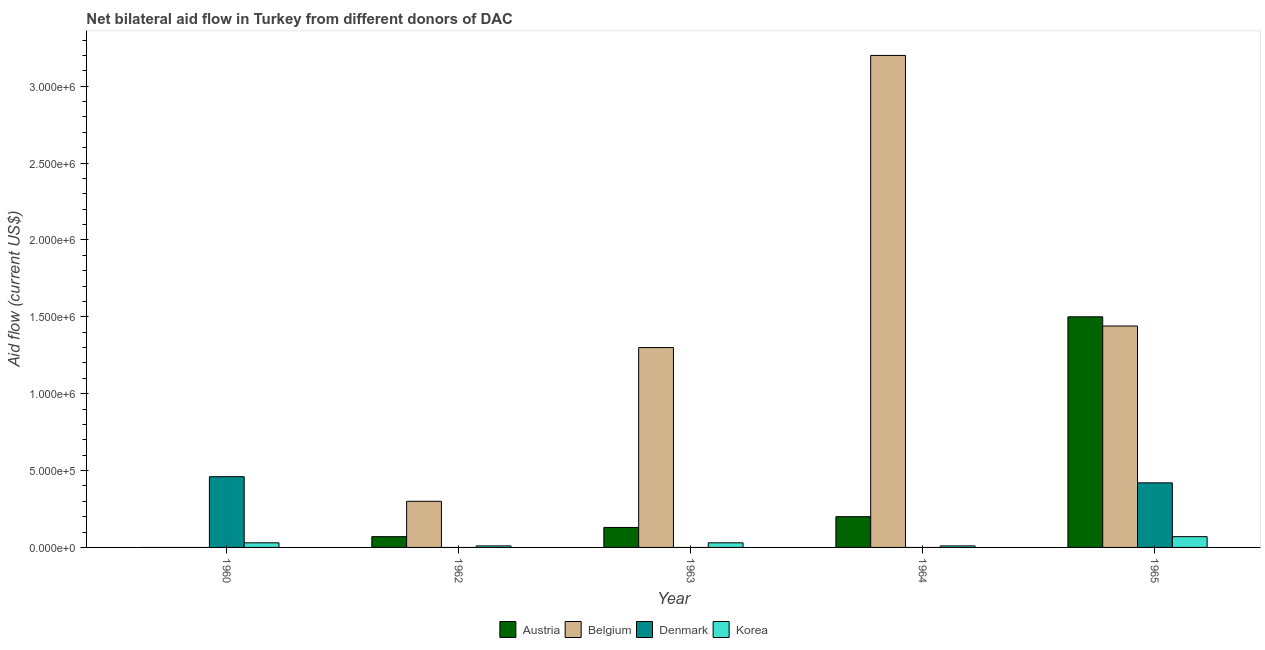How many different coloured bars are there?
Ensure brevity in your answer.  4. How many groups of bars are there?
Provide a succinct answer. 5. Are the number of bars per tick equal to the number of legend labels?
Your answer should be very brief. No. How many bars are there on the 2nd tick from the left?
Offer a terse response. 3. What is the label of the 5th group of bars from the left?
Your answer should be very brief. 1965. In how many cases, is the number of bars for a given year not equal to the number of legend labels?
Provide a short and direct response. 4. What is the amount of aid given by korea in 1963?
Make the answer very short. 3.00e+04. Across all years, what is the maximum amount of aid given by austria?
Your answer should be compact. 1.50e+06. Across all years, what is the minimum amount of aid given by denmark?
Provide a succinct answer. 0. In which year was the amount of aid given by korea maximum?
Your response must be concise. 1965. What is the total amount of aid given by austria in the graph?
Provide a short and direct response. 1.90e+06. What is the difference between the amount of aid given by belgium in 1963 and that in 1965?
Offer a terse response. -1.40e+05. What is the difference between the amount of aid given by austria in 1965 and the amount of aid given by denmark in 1962?
Offer a terse response. 1.43e+06. What is the average amount of aid given by belgium per year?
Offer a terse response. 1.25e+06. Is the amount of aid given by austria in 1962 less than that in 1964?
Your answer should be compact. Yes. Is the difference between the amount of aid given by austria in 1964 and 1965 greater than the difference between the amount of aid given by belgium in 1964 and 1965?
Provide a short and direct response. No. What is the difference between the highest and the lowest amount of aid given by austria?
Make the answer very short. 1.50e+06. Is it the case that in every year, the sum of the amount of aid given by austria and amount of aid given by korea is greater than the sum of amount of aid given by denmark and amount of aid given by belgium?
Keep it short and to the point. No. What is the difference between two consecutive major ticks on the Y-axis?
Offer a terse response. 5.00e+05. Are the values on the major ticks of Y-axis written in scientific E-notation?
Your answer should be compact. Yes. Where does the legend appear in the graph?
Make the answer very short. Bottom center. How many legend labels are there?
Give a very brief answer. 4. How are the legend labels stacked?
Provide a succinct answer. Horizontal. What is the title of the graph?
Make the answer very short. Net bilateral aid flow in Turkey from different donors of DAC. What is the Aid flow (current US$) in Denmark in 1960?
Your response must be concise. 4.60e+05. What is the Aid flow (current US$) of Denmark in 1962?
Your answer should be very brief. 0. What is the Aid flow (current US$) in Austria in 1963?
Make the answer very short. 1.30e+05. What is the Aid flow (current US$) of Belgium in 1963?
Give a very brief answer. 1.30e+06. What is the Aid flow (current US$) of Denmark in 1963?
Offer a very short reply. 0. What is the Aid flow (current US$) in Belgium in 1964?
Ensure brevity in your answer.  3.20e+06. What is the Aid flow (current US$) of Denmark in 1964?
Offer a very short reply. 0. What is the Aid flow (current US$) of Korea in 1964?
Your response must be concise. 10000. What is the Aid flow (current US$) of Austria in 1965?
Give a very brief answer. 1.50e+06. What is the Aid flow (current US$) in Belgium in 1965?
Give a very brief answer. 1.44e+06. What is the Aid flow (current US$) of Denmark in 1965?
Your response must be concise. 4.20e+05. What is the Aid flow (current US$) of Korea in 1965?
Your answer should be very brief. 7.00e+04. Across all years, what is the maximum Aid flow (current US$) in Austria?
Offer a very short reply. 1.50e+06. Across all years, what is the maximum Aid flow (current US$) of Belgium?
Your answer should be very brief. 3.20e+06. Across all years, what is the minimum Aid flow (current US$) of Austria?
Your response must be concise. 0. Across all years, what is the minimum Aid flow (current US$) of Belgium?
Your response must be concise. 0. What is the total Aid flow (current US$) of Austria in the graph?
Offer a terse response. 1.90e+06. What is the total Aid flow (current US$) of Belgium in the graph?
Ensure brevity in your answer.  6.24e+06. What is the total Aid flow (current US$) in Denmark in the graph?
Your response must be concise. 8.80e+05. What is the difference between the Aid flow (current US$) in Korea in 1960 and that in 1963?
Provide a short and direct response. 0. What is the difference between the Aid flow (current US$) in Denmark in 1960 and that in 1965?
Offer a terse response. 4.00e+04. What is the difference between the Aid flow (current US$) in Korea in 1960 and that in 1965?
Give a very brief answer. -4.00e+04. What is the difference between the Aid flow (current US$) of Austria in 1962 and that in 1963?
Ensure brevity in your answer.  -6.00e+04. What is the difference between the Aid flow (current US$) in Korea in 1962 and that in 1963?
Your response must be concise. -2.00e+04. What is the difference between the Aid flow (current US$) in Belgium in 1962 and that in 1964?
Your answer should be very brief. -2.90e+06. What is the difference between the Aid flow (current US$) in Austria in 1962 and that in 1965?
Provide a succinct answer. -1.43e+06. What is the difference between the Aid flow (current US$) in Belgium in 1962 and that in 1965?
Make the answer very short. -1.14e+06. What is the difference between the Aid flow (current US$) in Korea in 1962 and that in 1965?
Your response must be concise. -6.00e+04. What is the difference between the Aid flow (current US$) in Belgium in 1963 and that in 1964?
Provide a short and direct response. -1.90e+06. What is the difference between the Aid flow (current US$) of Austria in 1963 and that in 1965?
Give a very brief answer. -1.37e+06. What is the difference between the Aid flow (current US$) in Belgium in 1963 and that in 1965?
Offer a very short reply. -1.40e+05. What is the difference between the Aid flow (current US$) in Austria in 1964 and that in 1965?
Make the answer very short. -1.30e+06. What is the difference between the Aid flow (current US$) of Belgium in 1964 and that in 1965?
Your answer should be compact. 1.76e+06. What is the difference between the Aid flow (current US$) in Korea in 1964 and that in 1965?
Provide a succinct answer. -6.00e+04. What is the difference between the Aid flow (current US$) of Denmark in 1960 and the Aid flow (current US$) of Korea in 1962?
Your answer should be very brief. 4.50e+05. What is the difference between the Aid flow (current US$) in Denmark in 1960 and the Aid flow (current US$) in Korea in 1965?
Your answer should be very brief. 3.90e+05. What is the difference between the Aid flow (current US$) of Austria in 1962 and the Aid flow (current US$) of Belgium in 1963?
Provide a succinct answer. -1.23e+06. What is the difference between the Aid flow (current US$) of Austria in 1962 and the Aid flow (current US$) of Belgium in 1964?
Ensure brevity in your answer.  -3.13e+06. What is the difference between the Aid flow (current US$) in Austria in 1962 and the Aid flow (current US$) in Korea in 1964?
Ensure brevity in your answer.  6.00e+04. What is the difference between the Aid flow (current US$) in Austria in 1962 and the Aid flow (current US$) in Belgium in 1965?
Offer a terse response. -1.37e+06. What is the difference between the Aid flow (current US$) of Austria in 1962 and the Aid flow (current US$) of Denmark in 1965?
Offer a very short reply. -3.50e+05. What is the difference between the Aid flow (current US$) in Austria in 1962 and the Aid flow (current US$) in Korea in 1965?
Provide a short and direct response. 0. What is the difference between the Aid flow (current US$) of Belgium in 1962 and the Aid flow (current US$) of Korea in 1965?
Your response must be concise. 2.30e+05. What is the difference between the Aid flow (current US$) of Austria in 1963 and the Aid flow (current US$) of Belgium in 1964?
Your answer should be compact. -3.07e+06. What is the difference between the Aid flow (current US$) in Austria in 1963 and the Aid flow (current US$) in Korea in 1964?
Offer a terse response. 1.20e+05. What is the difference between the Aid flow (current US$) of Belgium in 1963 and the Aid flow (current US$) of Korea in 1964?
Offer a terse response. 1.29e+06. What is the difference between the Aid flow (current US$) in Austria in 1963 and the Aid flow (current US$) in Belgium in 1965?
Ensure brevity in your answer.  -1.31e+06. What is the difference between the Aid flow (current US$) in Austria in 1963 and the Aid flow (current US$) in Korea in 1965?
Provide a succinct answer. 6.00e+04. What is the difference between the Aid flow (current US$) in Belgium in 1963 and the Aid flow (current US$) in Denmark in 1965?
Make the answer very short. 8.80e+05. What is the difference between the Aid flow (current US$) in Belgium in 1963 and the Aid flow (current US$) in Korea in 1965?
Make the answer very short. 1.23e+06. What is the difference between the Aid flow (current US$) in Austria in 1964 and the Aid flow (current US$) in Belgium in 1965?
Your answer should be very brief. -1.24e+06. What is the difference between the Aid flow (current US$) of Belgium in 1964 and the Aid flow (current US$) of Denmark in 1965?
Ensure brevity in your answer.  2.78e+06. What is the difference between the Aid flow (current US$) of Belgium in 1964 and the Aid flow (current US$) of Korea in 1965?
Your answer should be very brief. 3.13e+06. What is the average Aid flow (current US$) in Austria per year?
Your answer should be very brief. 3.80e+05. What is the average Aid flow (current US$) of Belgium per year?
Give a very brief answer. 1.25e+06. What is the average Aid flow (current US$) in Denmark per year?
Keep it short and to the point. 1.76e+05. What is the average Aid flow (current US$) of Korea per year?
Provide a short and direct response. 3.00e+04. In the year 1962, what is the difference between the Aid flow (current US$) of Austria and Aid flow (current US$) of Belgium?
Your response must be concise. -2.30e+05. In the year 1963, what is the difference between the Aid flow (current US$) in Austria and Aid flow (current US$) in Belgium?
Ensure brevity in your answer.  -1.17e+06. In the year 1963, what is the difference between the Aid flow (current US$) in Austria and Aid flow (current US$) in Korea?
Provide a short and direct response. 1.00e+05. In the year 1963, what is the difference between the Aid flow (current US$) of Belgium and Aid flow (current US$) of Korea?
Make the answer very short. 1.27e+06. In the year 1964, what is the difference between the Aid flow (current US$) of Austria and Aid flow (current US$) of Belgium?
Your answer should be very brief. -3.00e+06. In the year 1964, what is the difference between the Aid flow (current US$) of Belgium and Aid flow (current US$) of Korea?
Keep it short and to the point. 3.19e+06. In the year 1965, what is the difference between the Aid flow (current US$) in Austria and Aid flow (current US$) in Belgium?
Provide a succinct answer. 6.00e+04. In the year 1965, what is the difference between the Aid flow (current US$) in Austria and Aid flow (current US$) in Denmark?
Offer a very short reply. 1.08e+06. In the year 1965, what is the difference between the Aid flow (current US$) of Austria and Aid flow (current US$) of Korea?
Keep it short and to the point. 1.43e+06. In the year 1965, what is the difference between the Aid flow (current US$) of Belgium and Aid flow (current US$) of Denmark?
Your response must be concise. 1.02e+06. In the year 1965, what is the difference between the Aid flow (current US$) of Belgium and Aid flow (current US$) of Korea?
Ensure brevity in your answer.  1.37e+06. What is the ratio of the Aid flow (current US$) of Korea in 1960 to that in 1962?
Your response must be concise. 3. What is the ratio of the Aid flow (current US$) of Korea in 1960 to that in 1964?
Your answer should be very brief. 3. What is the ratio of the Aid flow (current US$) in Denmark in 1960 to that in 1965?
Offer a very short reply. 1.1. What is the ratio of the Aid flow (current US$) of Korea in 1960 to that in 1965?
Your answer should be very brief. 0.43. What is the ratio of the Aid flow (current US$) of Austria in 1962 to that in 1963?
Your answer should be compact. 0.54. What is the ratio of the Aid flow (current US$) of Belgium in 1962 to that in 1963?
Your answer should be very brief. 0.23. What is the ratio of the Aid flow (current US$) in Austria in 1962 to that in 1964?
Give a very brief answer. 0.35. What is the ratio of the Aid flow (current US$) of Belgium in 1962 to that in 1964?
Provide a succinct answer. 0.09. What is the ratio of the Aid flow (current US$) in Austria in 1962 to that in 1965?
Give a very brief answer. 0.05. What is the ratio of the Aid flow (current US$) in Belgium in 1962 to that in 1965?
Provide a short and direct response. 0.21. What is the ratio of the Aid flow (current US$) in Korea in 1962 to that in 1965?
Provide a succinct answer. 0.14. What is the ratio of the Aid flow (current US$) in Austria in 1963 to that in 1964?
Make the answer very short. 0.65. What is the ratio of the Aid flow (current US$) of Belgium in 1963 to that in 1964?
Provide a succinct answer. 0.41. What is the ratio of the Aid flow (current US$) in Korea in 1963 to that in 1964?
Make the answer very short. 3. What is the ratio of the Aid flow (current US$) in Austria in 1963 to that in 1965?
Your answer should be very brief. 0.09. What is the ratio of the Aid flow (current US$) of Belgium in 1963 to that in 1965?
Offer a very short reply. 0.9. What is the ratio of the Aid flow (current US$) in Korea in 1963 to that in 1965?
Provide a succinct answer. 0.43. What is the ratio of the Aid flow (current US$) in Austria in 1964 to that in 1965?
Give a very brief answer. 0.13. What is the ratio of the Aid flow (current US$) of Belgium in 1964 to that in 1965?
Offer a very short reply. 2.22. What is the ratio of the Aid flow (current US$) of Korea in 1964 to that in 1965?
Offer a terse response. 0.14. What is the difference between the highest and the second highest Aid flow (current US$) in Austria?
Your answer should be very brief. 1.30e+06. What is the difference between the highest and the second highest Aid flow (current US$) of Belgium?
Your response must be concise. 1.76e+06. What is the difference between the highest and the second highest Aid flow (current US$) in Korea?
Keep it short and to the point. 4.00e+04. What is the difference between the highest and the lowest Aid flow (current US$) of Austria?
Provide a succinct answer. 1.50e+06. What is the difference between the highest and the lowest Aid flow (current US$) in Belgium?
Your answer should be compact. 3.20e+06. What is the difference between the highest and the lowest Aid flow (current US$) in Denmark?
Keep it short and to the point. 4.60e+05. 